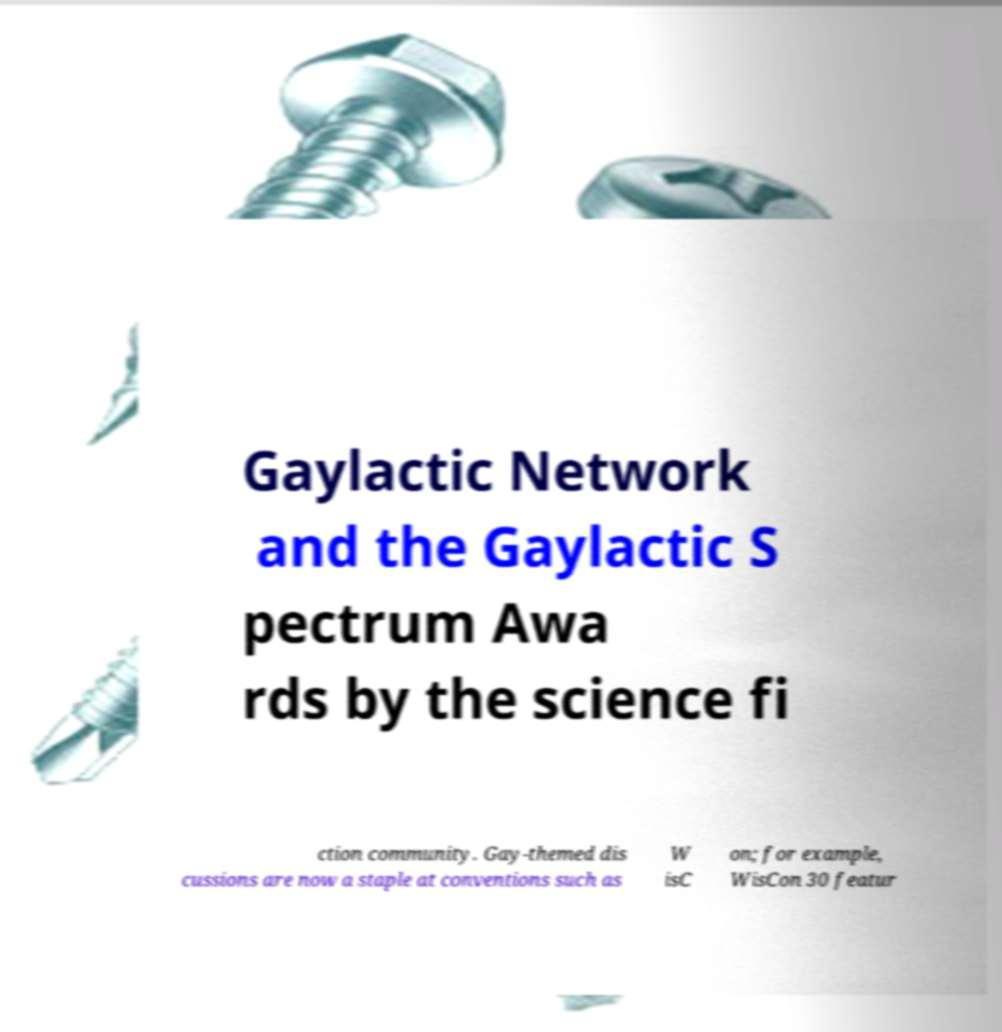For documentation purposes, I need the text within this image transcribed. Could you provide that? Gaylactic Network and the Gaylactic S pectrum Awa rds by the science fi ction community. Gay-themed dis cussions are now a staple at conventions such as W isC on; for example, WisCon 30 featur 